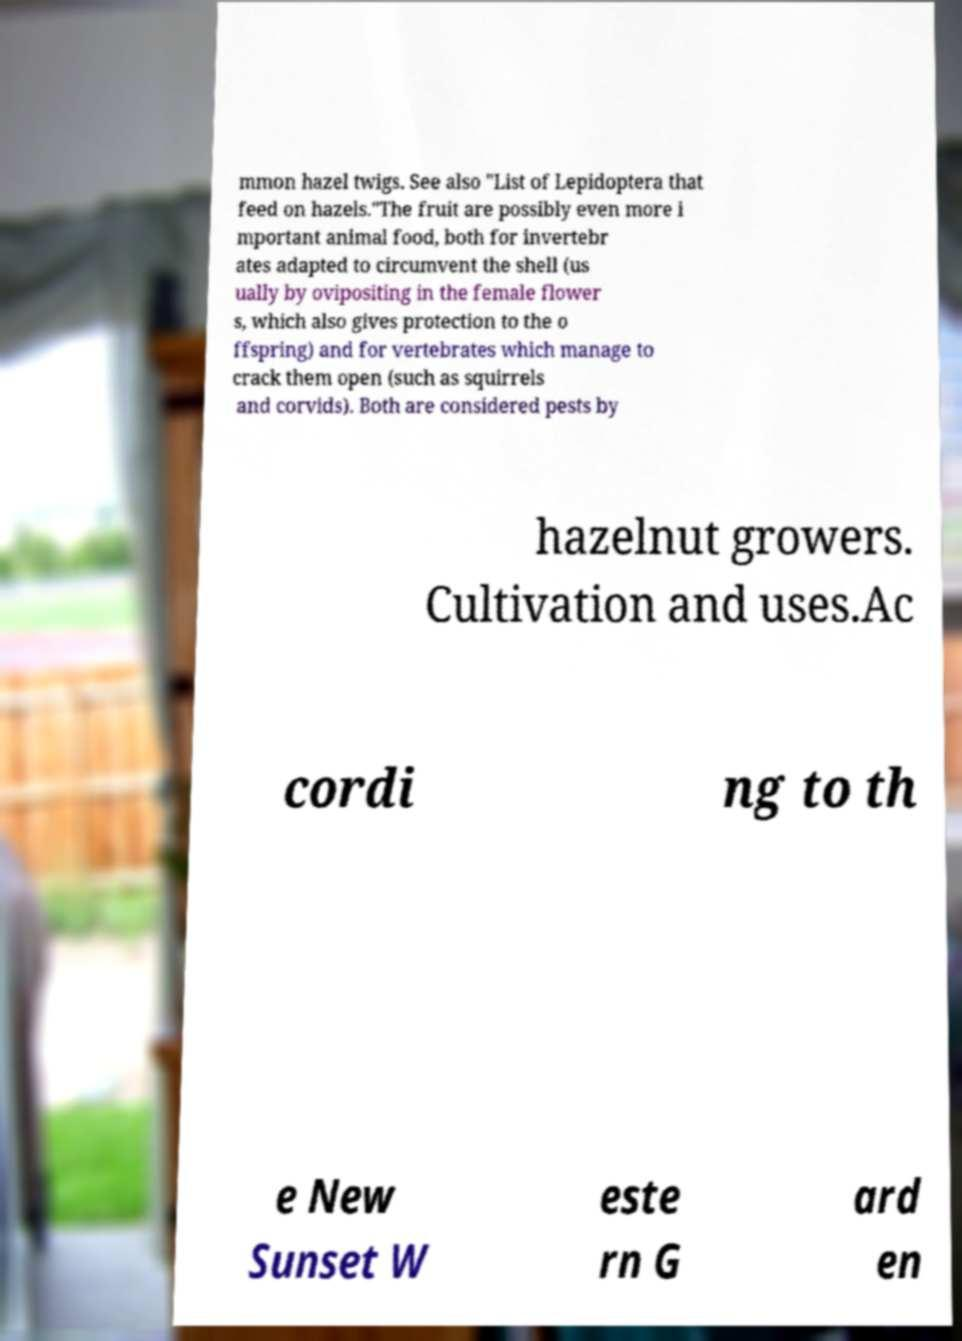There's text embedded in this image that I need extracted. Can you transcribe it verbatim? mmon hazel twigs. See also "List of Lepidoptera that feed on hazels."The fruit are possibly even more i mportant animal food, both for invertebr ates adapted to circumvent the shell (us ually by ovipositing in the female flower s, which also gives protection to the o ffspring) and for vertebrates which manage to crack them open (such as squirrels and corvids). Both are considered pests by hazelnut growers. Cultivation and uses.Ac cordi ng to th e New Sunset W este rn G ard en 